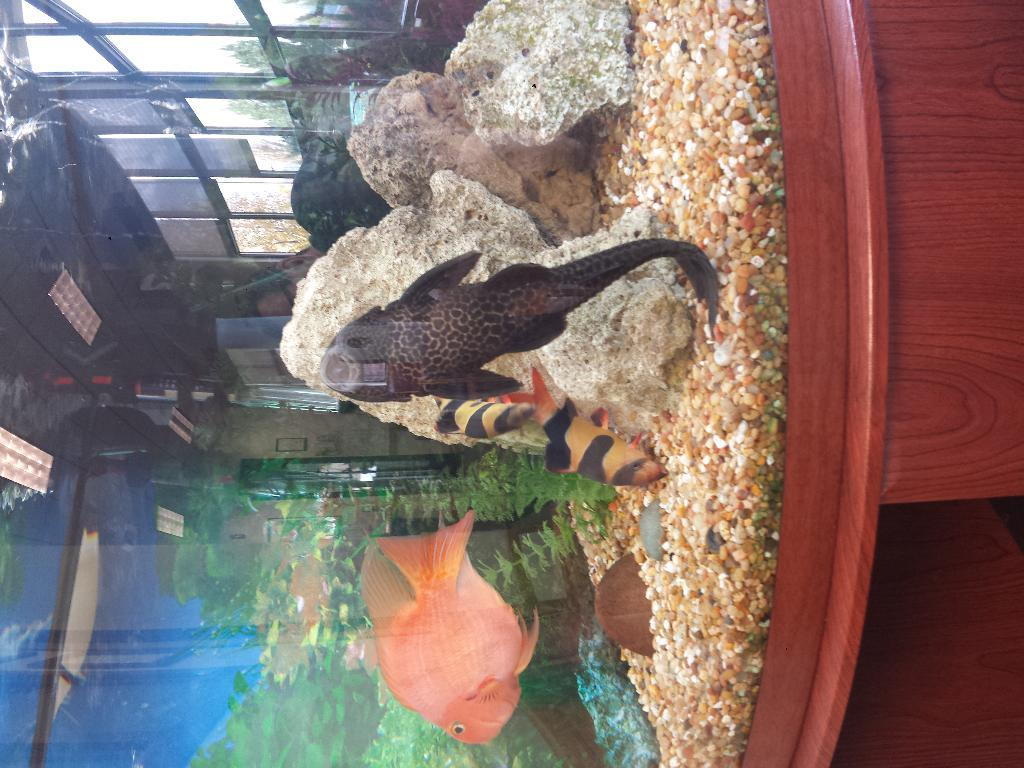What can be seen in the image? There is an aquarium in the image. What is inside the aquarium? There are fishes in the aquarium. What type of yard can be seen in the image? There is no yard present in the image; it features an aquarium with fishes. How does the temper of the fishes affect the water temperature in the image? The image does not provide information about the temper of the fishes or the water temperature, so it cannot be determined from the image. 